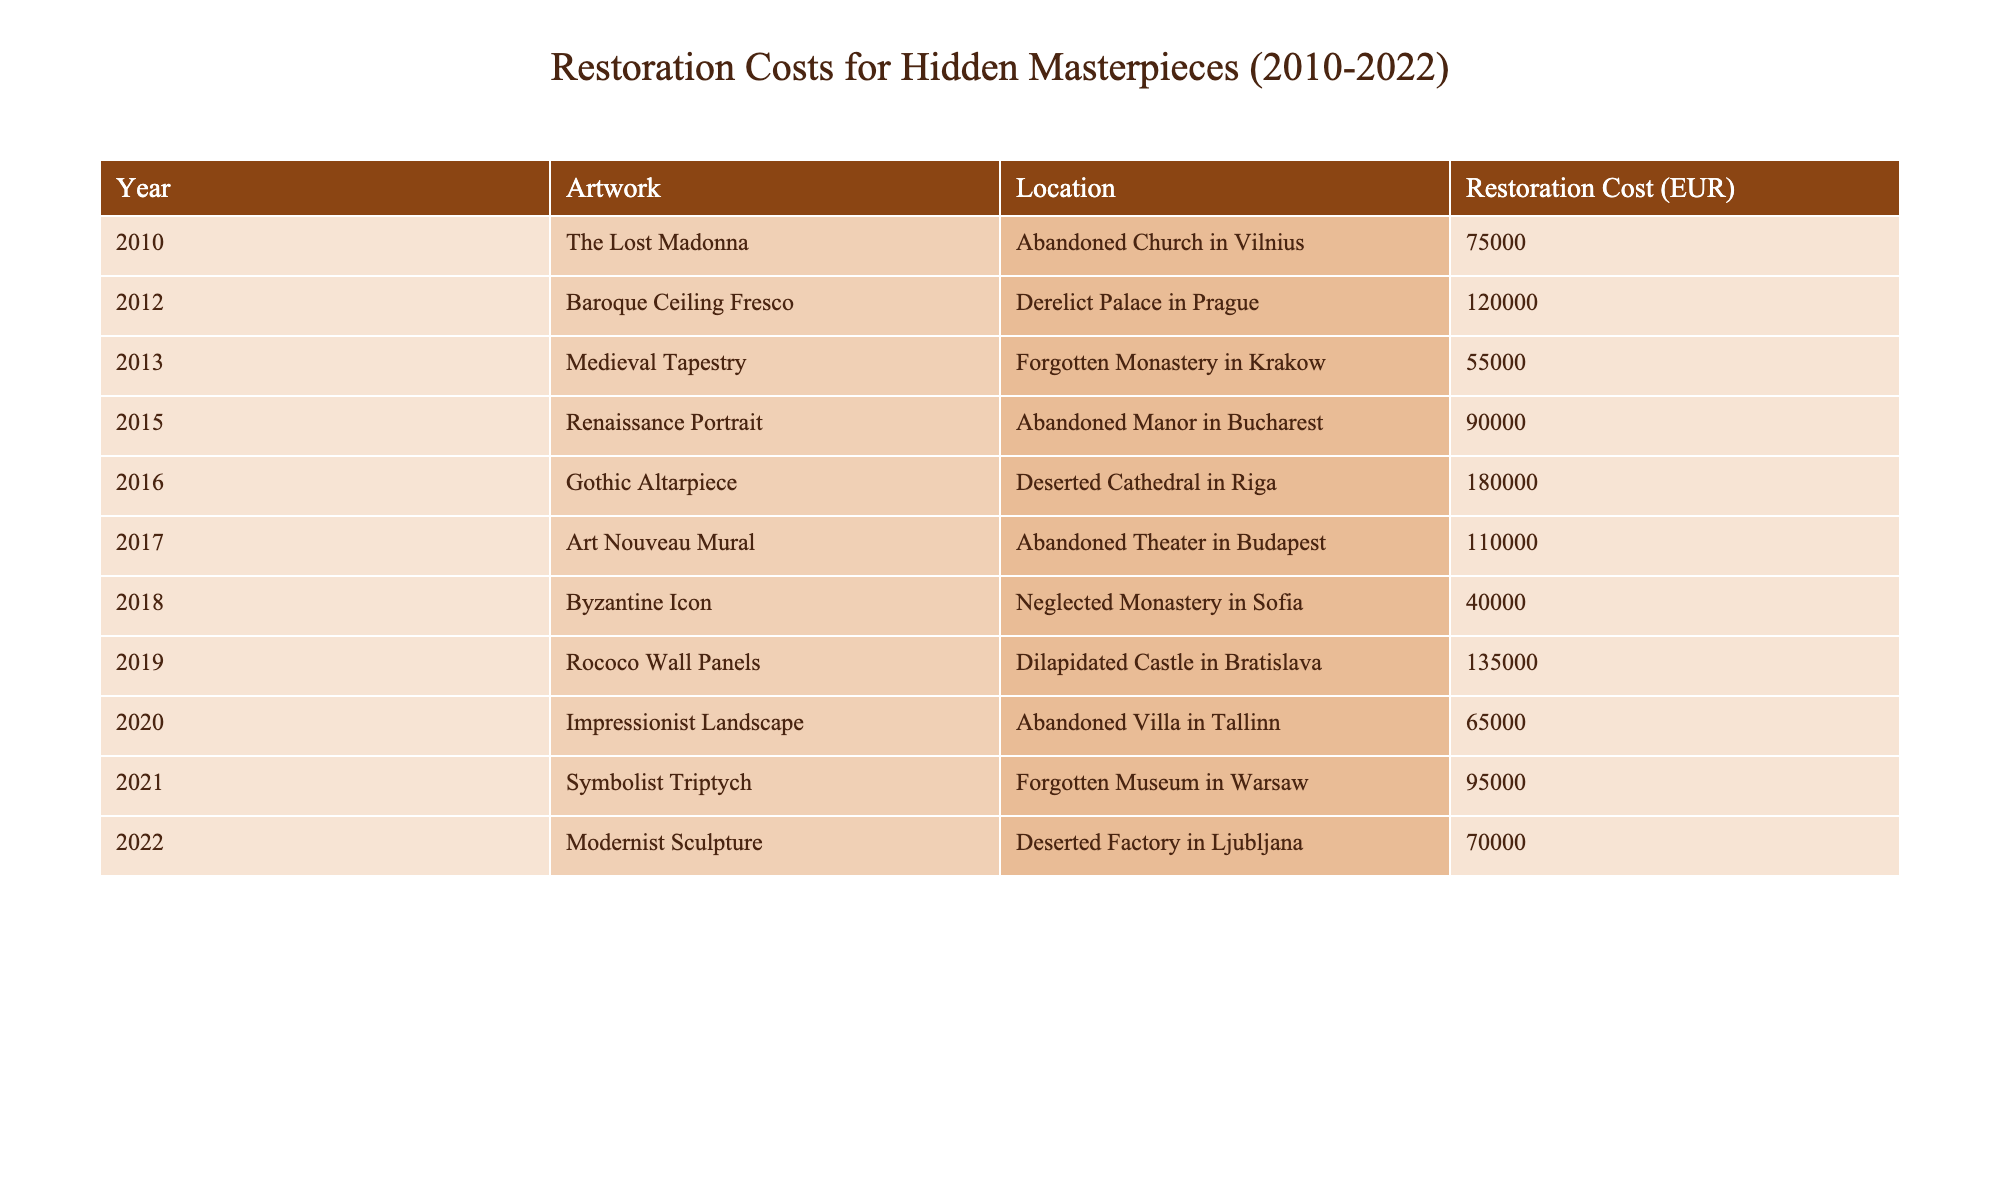What is the restoration cost of the Renaissance Portrait? The table shows that the restoration cost for the Renaissance Portrait is listed next to the artwork name, which is 90,000 EUR.
Answer: 90,000 EUR Which artwork had the highest restoration cost? By examining the costs listed for each artwork, the Gothic Altarpiece, with a restoration cost of 180,000 EUR, has the highest value in the table.
Answer: Gothic Altarpiece What is the total restoration cost of all artworks listed? The total restoration cost can be calculated by adding each cost: 75,000 + 120,000 + 55,000 + 90,000 + 180,000 + 110,000 + 40,000 + 135,000 + 65,000 + 95,000 + 70,000 = 1,145,000 EUR.
Answer: 1,145,000 EUR How many artworks had a restoration cost greater than 100,000 EUR? Looking at the table, the artworks with costs above 100,000 EUR are: Baroque Ceiling Fresco (120,000), Gothic Altarpiece (180,000), Art Nouveau Mural (110,000), and Rococo Wall Panels (135,000). This gives a total of four artworks.
Answer: 4 What is the average restoration cost of the masterpieces from 2010 to 2022? First, calculate the total restoration cost as 1,145,000 EUR. Then, since there are 11 artworks listed, divide 1,145,000 by 11 to find the average: 1,145,000 / 11 ≈ 104,091 EUR.
Answer: 104,091 EUR Which artwork found in 2018 had the lowest restoration cost? In 2018, the Byzantine Icon had a restoration cost of 40,000 EUR. This is the lowest cost for that year when compared to other artworks.
Answer: Byzantine Icon Did any artwork’s restoration cost decrease from the previous year? Comparing the costs of artworks in consecutive years, the restoration cost of the Impressionist Landscape in 2020 (65,000 EUR) decreased from the Symbolist Triptych in 2021 (95,000 EUR). So, the answer is yes.
Answer: Yes What is the difference in restoration costs between the artwork in 2013 and that in 2016? The Medieval Tapestry (2013) costs 55,000 EUR, while the Gothic Altarpiece (2016) costs 180,000 EUR. The difference can be calculated as 180,000 - 55,000 = 125,000 EUR.
Answer: 125,000 EUR Which city has the most expensive artwork restoration cost listed, and what is the artwork? By reviewing the table, the Gothic Altarpiece from Riga is the most expensive at 180,000 EUR, making Riga the city with the highest cost.
Answer: Riga, Gothic Altarpiece 